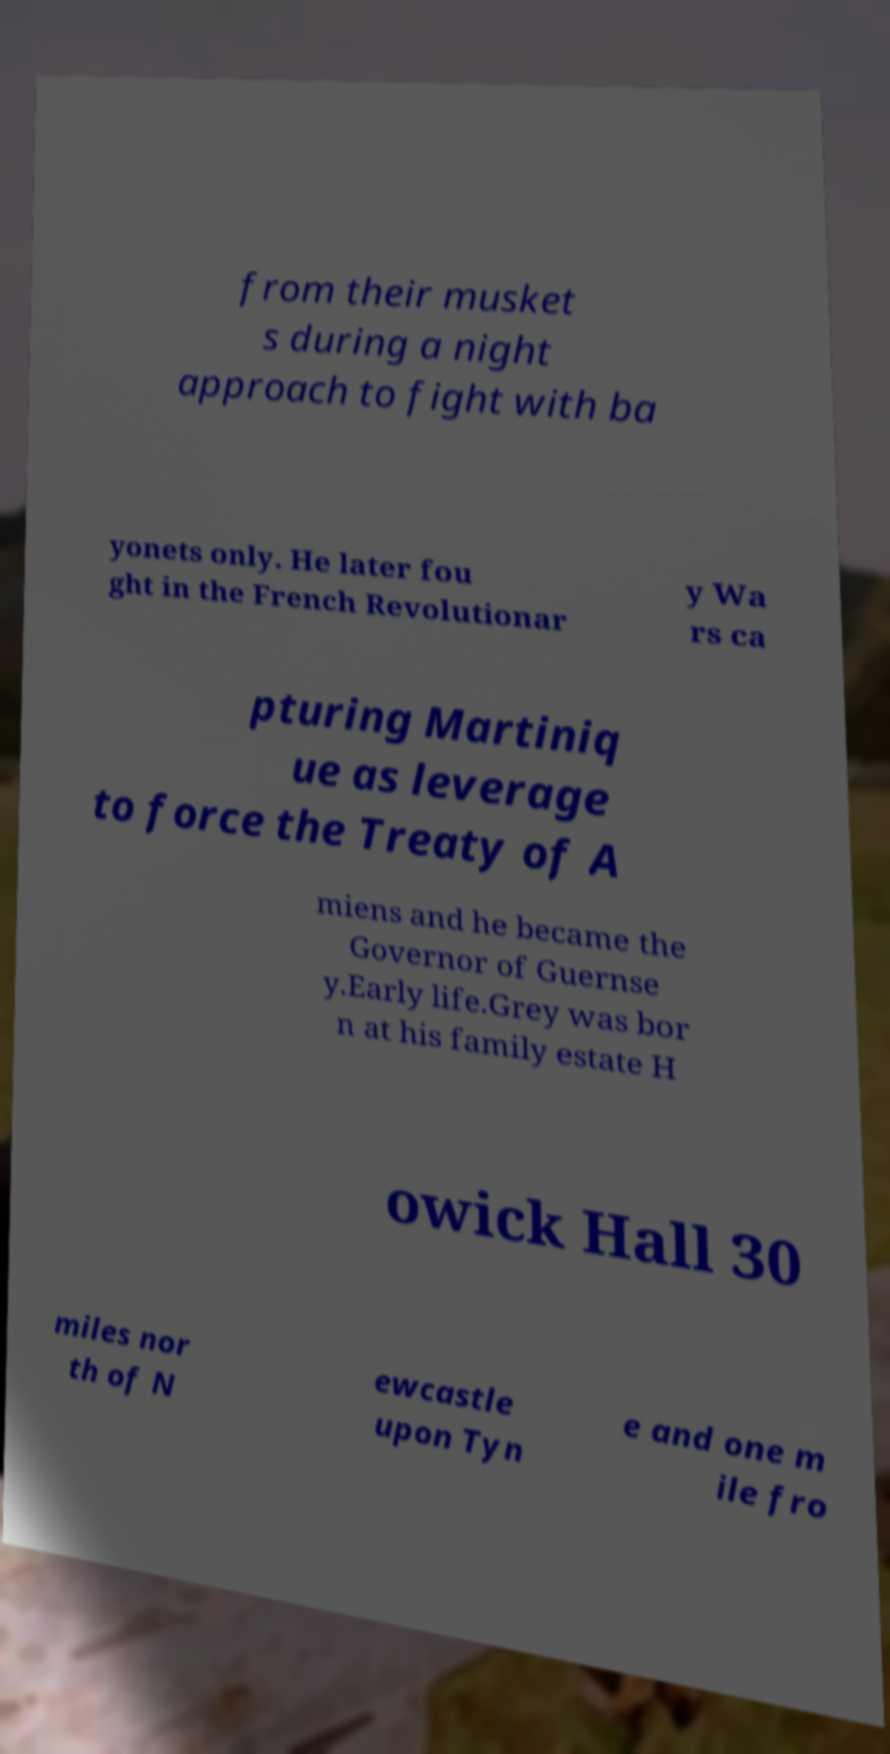Please read and relay the text visible in this image. What does it say? from their musket s during a night approach to fight with ba yonets only. He later fou ght in the French Revolutionar y Wa rs ca pturing Martiniq ue as leverage to force the Treaty of A miens and he became the Governor of Guernse y.Early life.Grey was bor n at his family estate H owick Hall 30 miles nor th of N ewcastle upon Tyn e and one m ile fro 